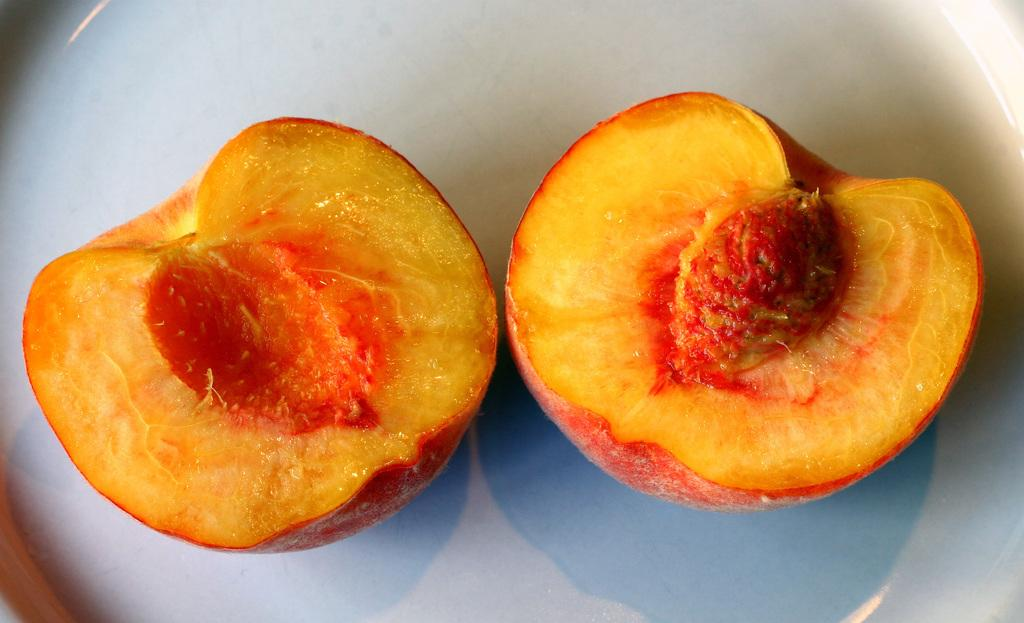What type of food can be seen in the image? There are fruits in the image. How are the fruits arranged or displayed in the image? The fruits are placed on a plate. What type of lead can be seen in the image? There is no lead present in the image; it features fruits placed on a plate. What kind of sponge is being used to clean the fruits in the image? There is no sponge or cleaning activity depicted in the image; it only shows fruits on a plate. 